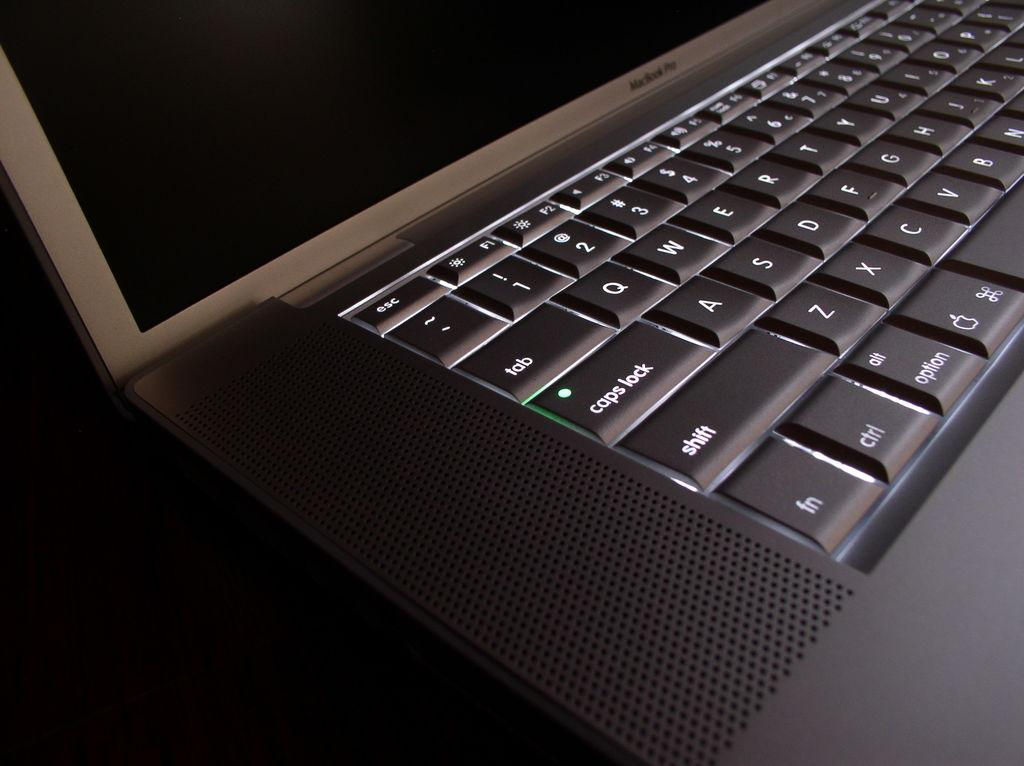<image>
Describe the image concisely. the left side of a lap top keyboard, it shows caps lock and shift amoung other things. 